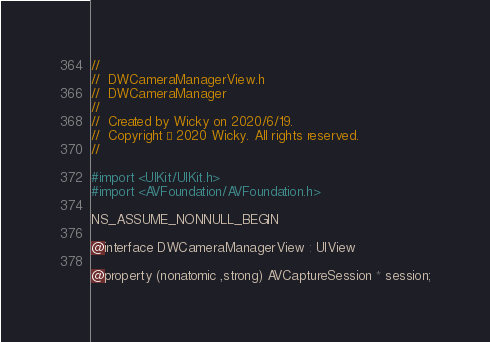<code> <loc_0><loc_0><loc_500><loc_500><_C_>//
//  DWCameraManagerView.h
//  DWCameraManager
//
//  Created by Wicky on 2020/6/19.
//  Copyright © 2020 Wicky. All rights reserved.
//

#import <UIKit/UIKit.h>
#import <AVFoundation/AVFoundation.h>

NS_ASSUME_NONNULL_BEGIN

@interface DWCameraManagerView : UIView

@property (nonatomic ,strong) AVCaptureSession * session;
</code> 